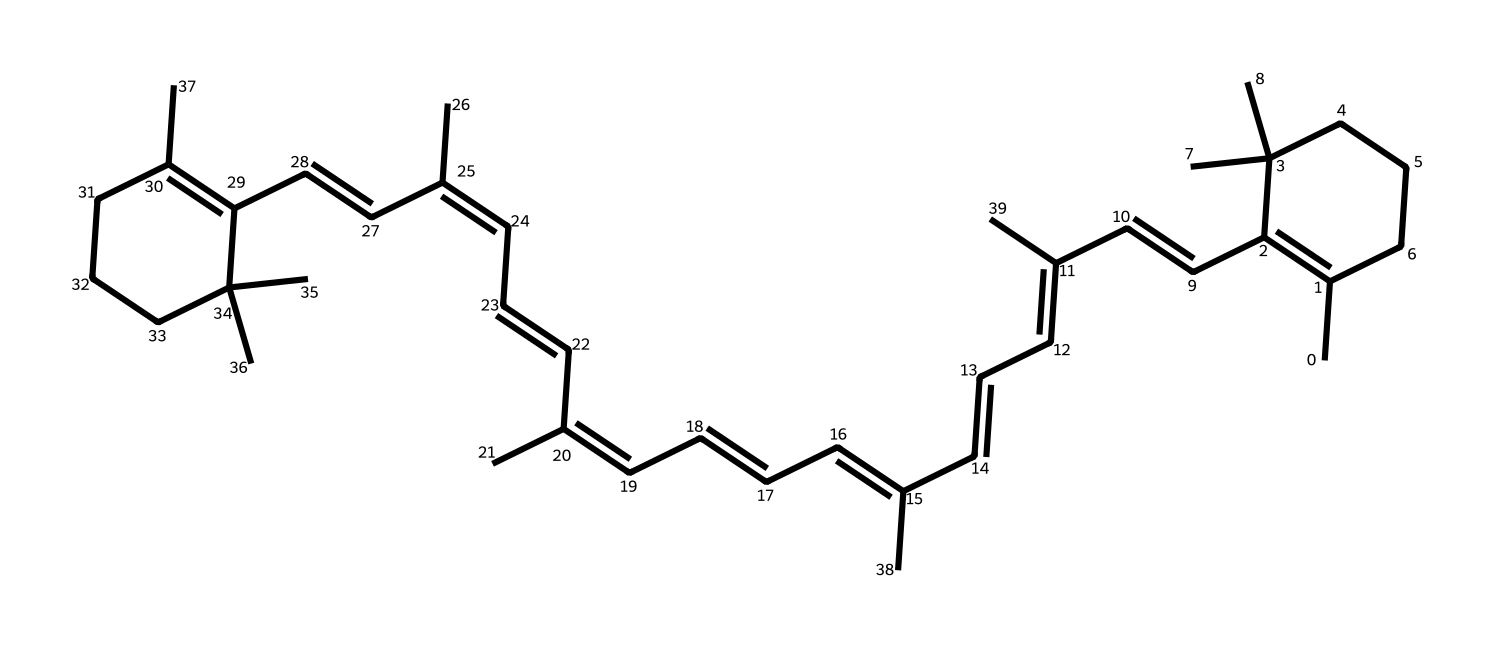What is the molecular formula of beta-carotene? To determine the molecular formula, we count all the carbon (C), hydrogen (H), and oxygen (O) atoms in the SMILES. The SMILES indicates a count of 40 carbon atoms and 56 hydrogen atoms, with no oxygen atoms mentioned. Thus, the molecular formula is C40H56.
Answer: C40H56 How many double bonds are present in beta-carotene? By analyzing the structure, we can see that beta-carotene contains 11 double bonds. This is determined by identifying the alternating double bonds throughout the conjugated system in the structure.
Answer: 11 What type of compound is beta-carotene classified as? Beta-carotene is classified as a carotenoid, a type of tetraterpene. The structure reveals a long hydrocarbon chain with conjugated double bonds, characteristic of this class of compounds.
Answer: carotenoid How many rings are present in the structure of beta-carotene? A careful examination of the structure indicates that beta-carotene does not contain any cyclic rings. The entire structure is a linear chain with multiple double bonds and side chains.
Answer: 0 What is the primary visual feature of beta-carotene that reflects its color? The extensive system of conjugated double bonds allows beta-carotene to absorb light in the ultraviolet and visible spectrum, especially in the blue-green region, leading to its characteristic orange color.
Answer: conjugated double bonds Which part of the beta-carotene structure enhances its stability? The presence of multiple conjugated double bonds contributes to the stability of beta-carotene through resonance, which helps to distribute electron density evenly across the molecule.
Answer: conjugated double bonds 